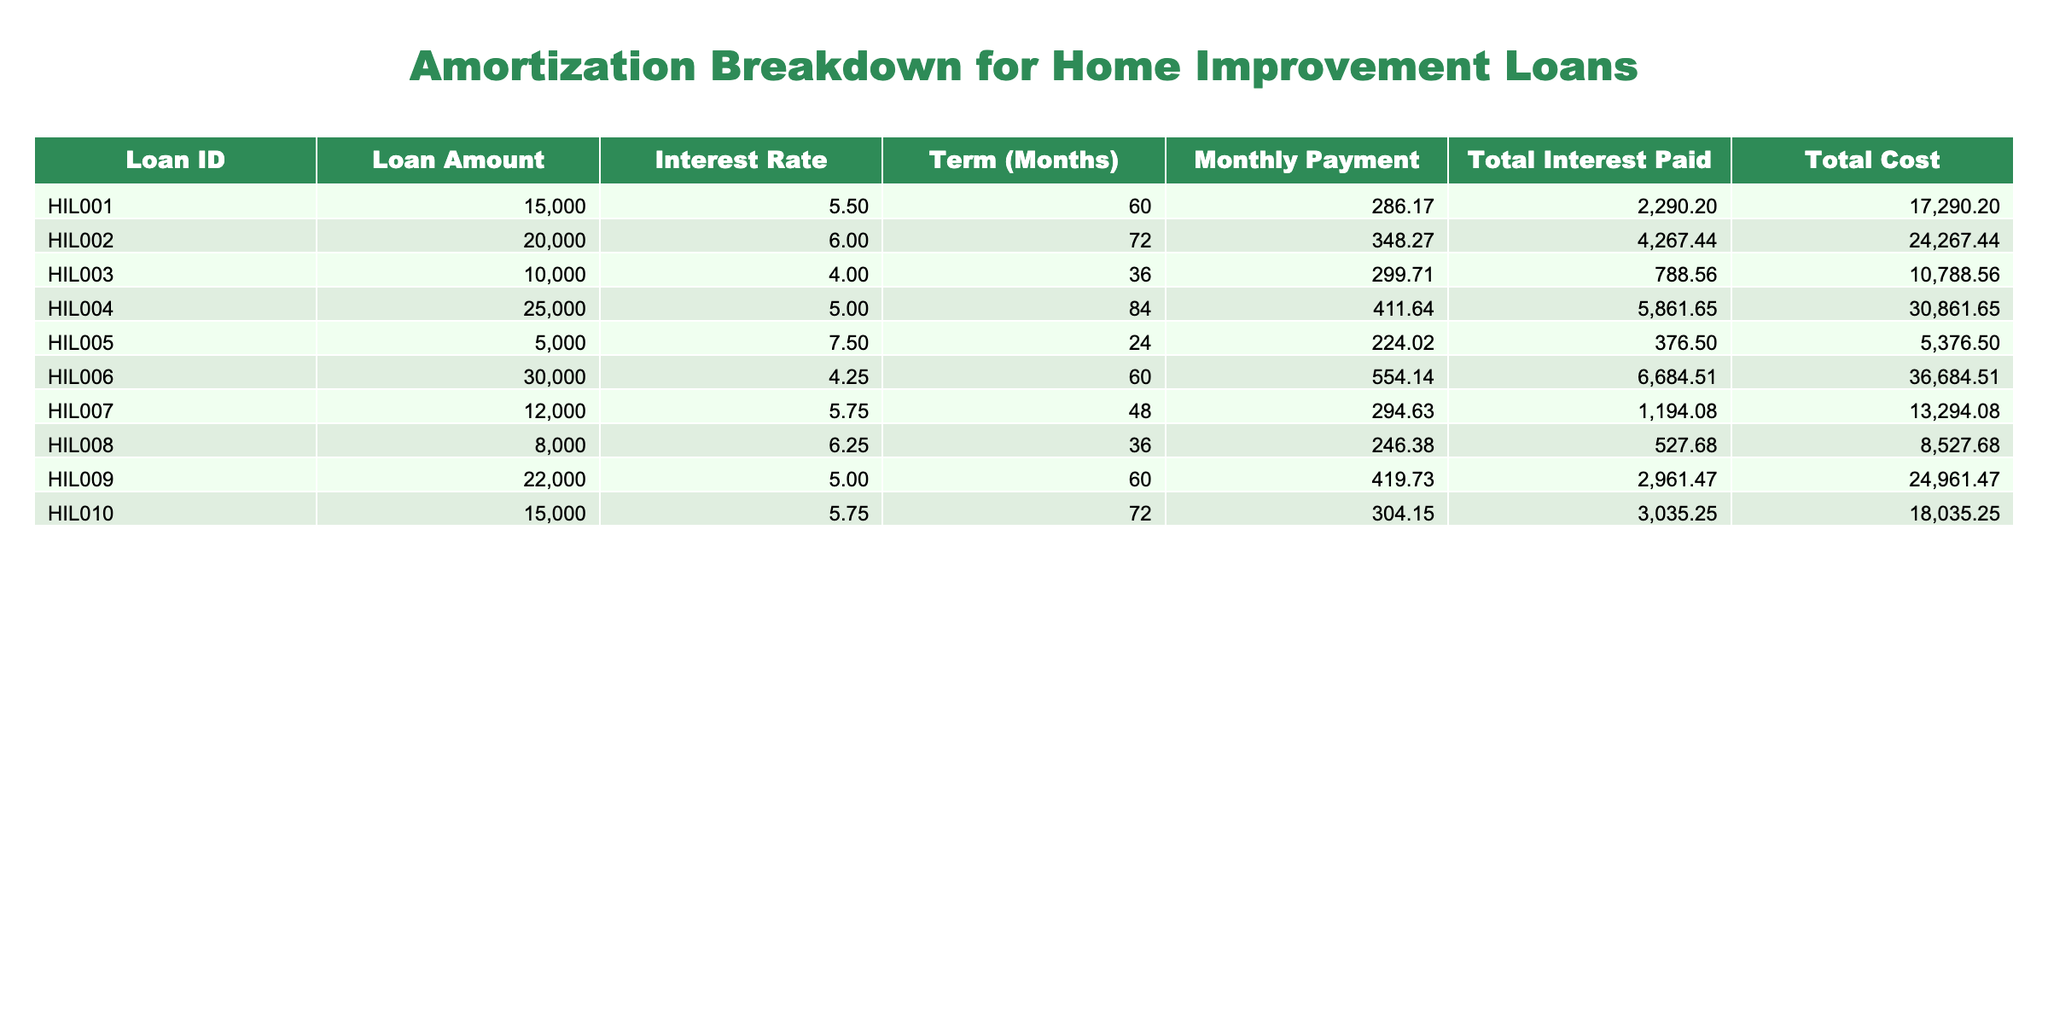What is the loan amount for Loan ID HIL004? By locating the specific row that contains Loan ID HIL004 in the table, we can see that the Loan Amount listed next to it is $25000.
Answer: 25000 What is the total interest paid for the loan with the highest interest rate? First, we identify the interest rates in the table. The highest interest rate is 7.5% for HIL005. Checking the Total Interest Paid column, it shows $376.50.
Answer: 376.50 What is the difference in total cost between Loan ID HIL002 and Loan ID HIL010? We find the total costs of each loan: HIL002 has a Total Cost of $24267.44 and HIL010 has $18035.25. The difference is calculated as 24267.44 - 18035.25 = $6232.19.
Answer: 6232.19 Is the monthly payment for Loan ID HIL008 greater than $250? Checking the Monthly Payment column for Loan HIL008, we see it is $246.38, which is less than $250. Therefore, the answer is no.
Answer: No What is the average total interest paid across all loans? To find the average, sum up all the Total Interest Paid values: (2290.20 + 4267.44 + 788.56 + 5861.65 + 376.50 + 6684.51 + 1194.08 + 527.68 + 2961.47 + 3035.25) which equals 18618.34. There are 10 loans, so we divide the total by 10, yielding an average of 1861.83.
Answer: 1861.83 